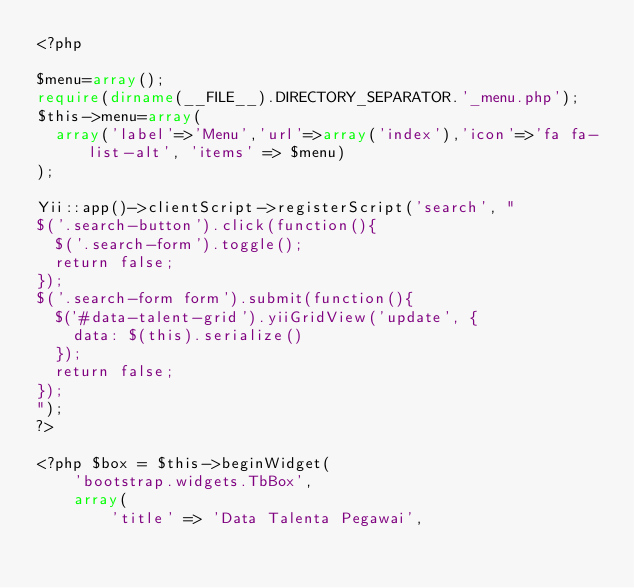<code> <loc_0><loc_0><loc_500><loc_500><_PHP_><?php

$menu=array();
require(dirname(__FILE__).DIRECTORY_SEPARATOR.'_menu.php');
$this->menu=array(
	array('label'=>'Menu','url'=>array('index'),'icon'=>'fa fa-list-alt', 'items' => $menu)	
);

Yii::app()->clientScript->registerScript('search', "
$('.search-button').click(function(){
	$('.search-form').toggle();
	return false;
});
$('.search-form form').submit(function(){
	$('#data-talent-grid').yiiGridView('update', {
		data: $(this).serialize()
	});
	return false;
});
");
?>

<?php $box = $this->beginWidget(
    'bootstrap.widgets.TbBox',
    array(
        'title' => 'Data Talenta Pegawai',</code> 